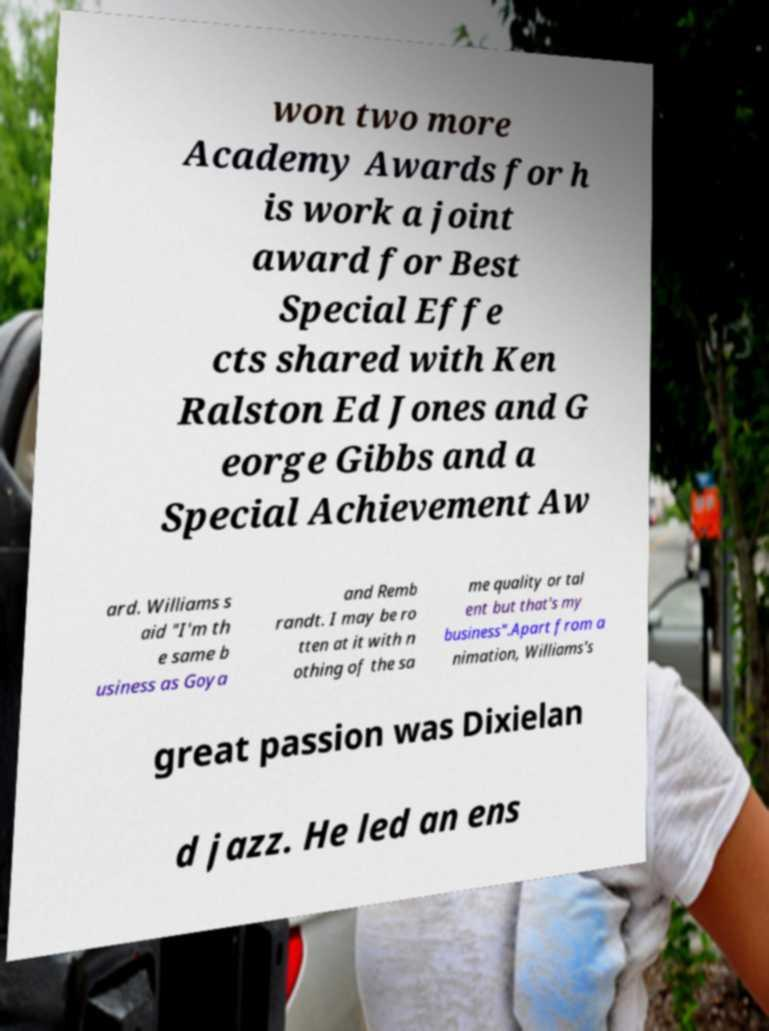Can you read and provide the text displayed in the image?This photo seems to have some interesting text. Can you extract and type it out for me? won two more Academy Awards for h is work a joint award for Best Special Effe cts shared with Ken Ralston Ed Jones and G eorge Gibbs and a Special Achievement Aw ard. Williams s aid "I'm th e same b usiness as Goya and Remb randt. I may be ro tten at it with n othing of the sa me quality or tal ent but that's my business".Apart from a nimation, Williams's great passion was Dixielan d jazz. He led an ens 